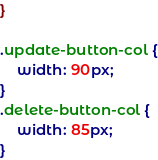Convert code to text. <code><loc_0><loc_0><loc_500><loc_500><_CSS_>}

.update-button-col {
    width: 90px;
}
.delete-button-col {
    width: 85px;
}
</code> 